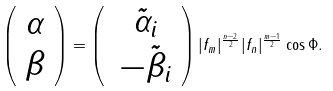Convert formula to latex. <formula><loc_0><loc_0><loc_500><loc_500>\left ( \begin{array} { c } \alpha \\ \beta \end{array} \right ) = \left ( \begin{array} { c } \, \tilde { \alpha } _ { i } \\ \, - \tilde { \beta } _ { i } \end{array} \right ) | f _ { m } | ^ { \frac { n - 2 } { 2 } } | f _ { n } | ^ { \frac { m - 1 } { 2 } } \cos \Phi .</formula> 